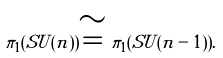<formula> <loc_0><loc_0><loc_500><loc_500>\pi _ { 1 } ( S U ( n ) ) \cong \pi _ { 1 } ( S U ( n - 1 ) ) .</formula> 